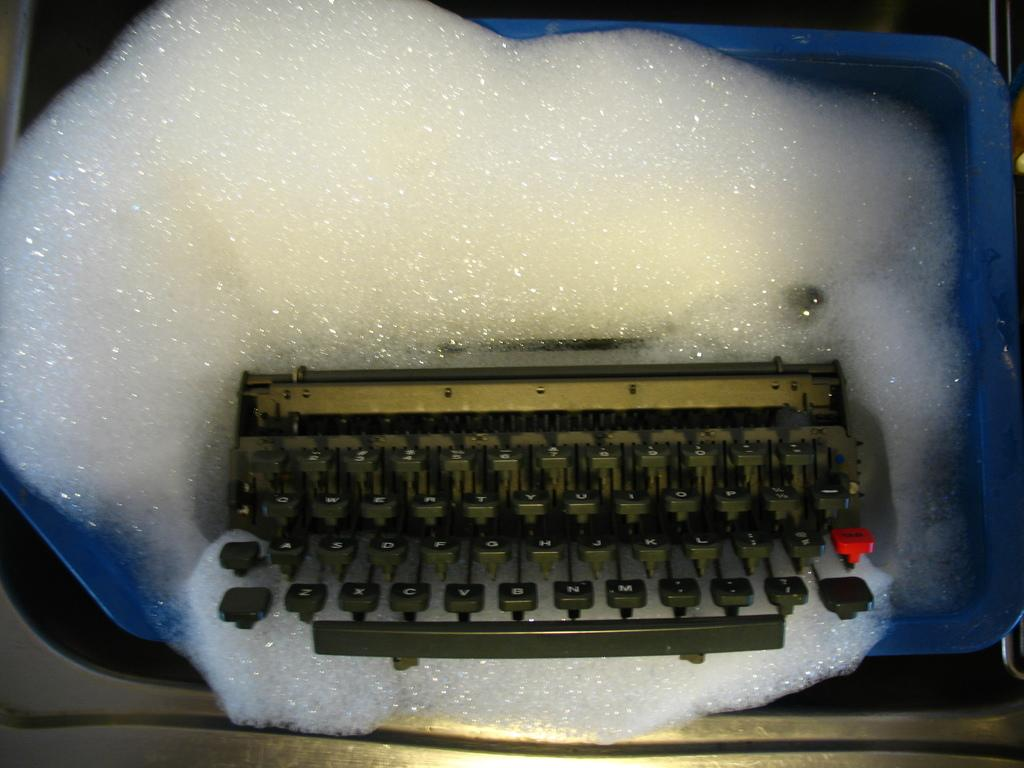<image>
Summarize the visual content of the image. An old typewriter with one red key that is three keys right of the L key. 